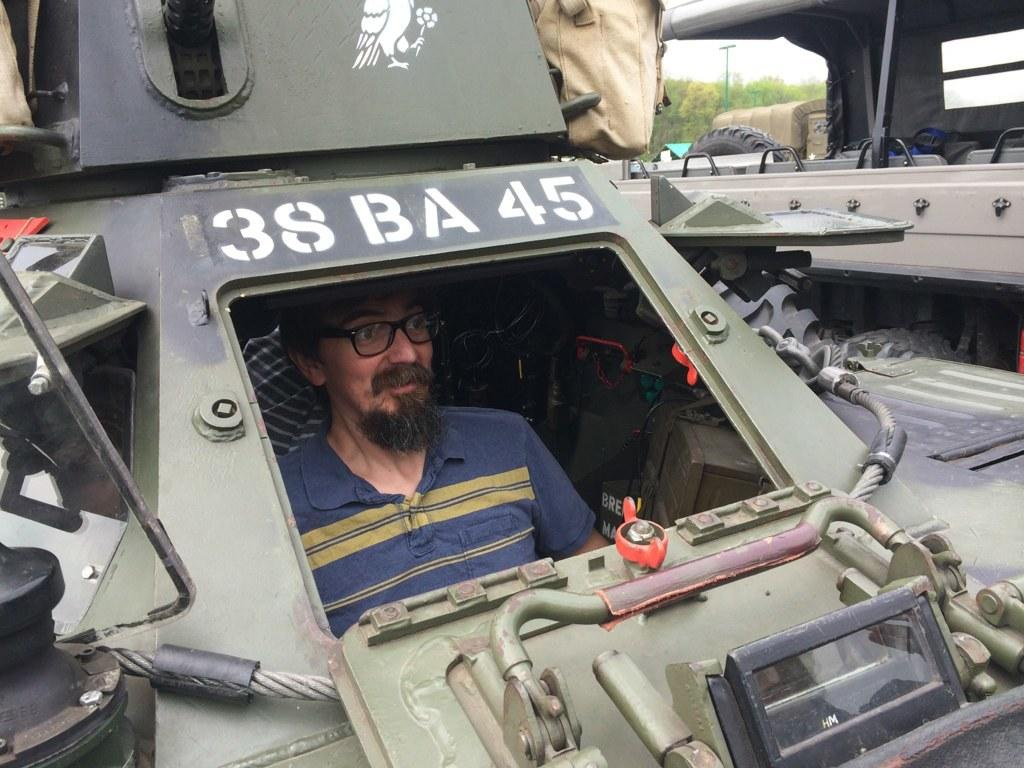What is happening in the image involving a person? There is a person in a vehicle in the image. What objects can be seen in the image besides the vehicles? There are rods, a bag, and some text visible in the image. What is present at the top of the image? Trees, poles, a tyre, and the sky are visible at the top of the image. How many vehicles are in the image? There are two vehicles in the image. What type of bun is being used as a steering wheel in the image? There is no bun present in the image, let alone one being used as a steering wheel. What kind of coach can be seen in the image? There is no coach present in the image; it features two vehicles. 